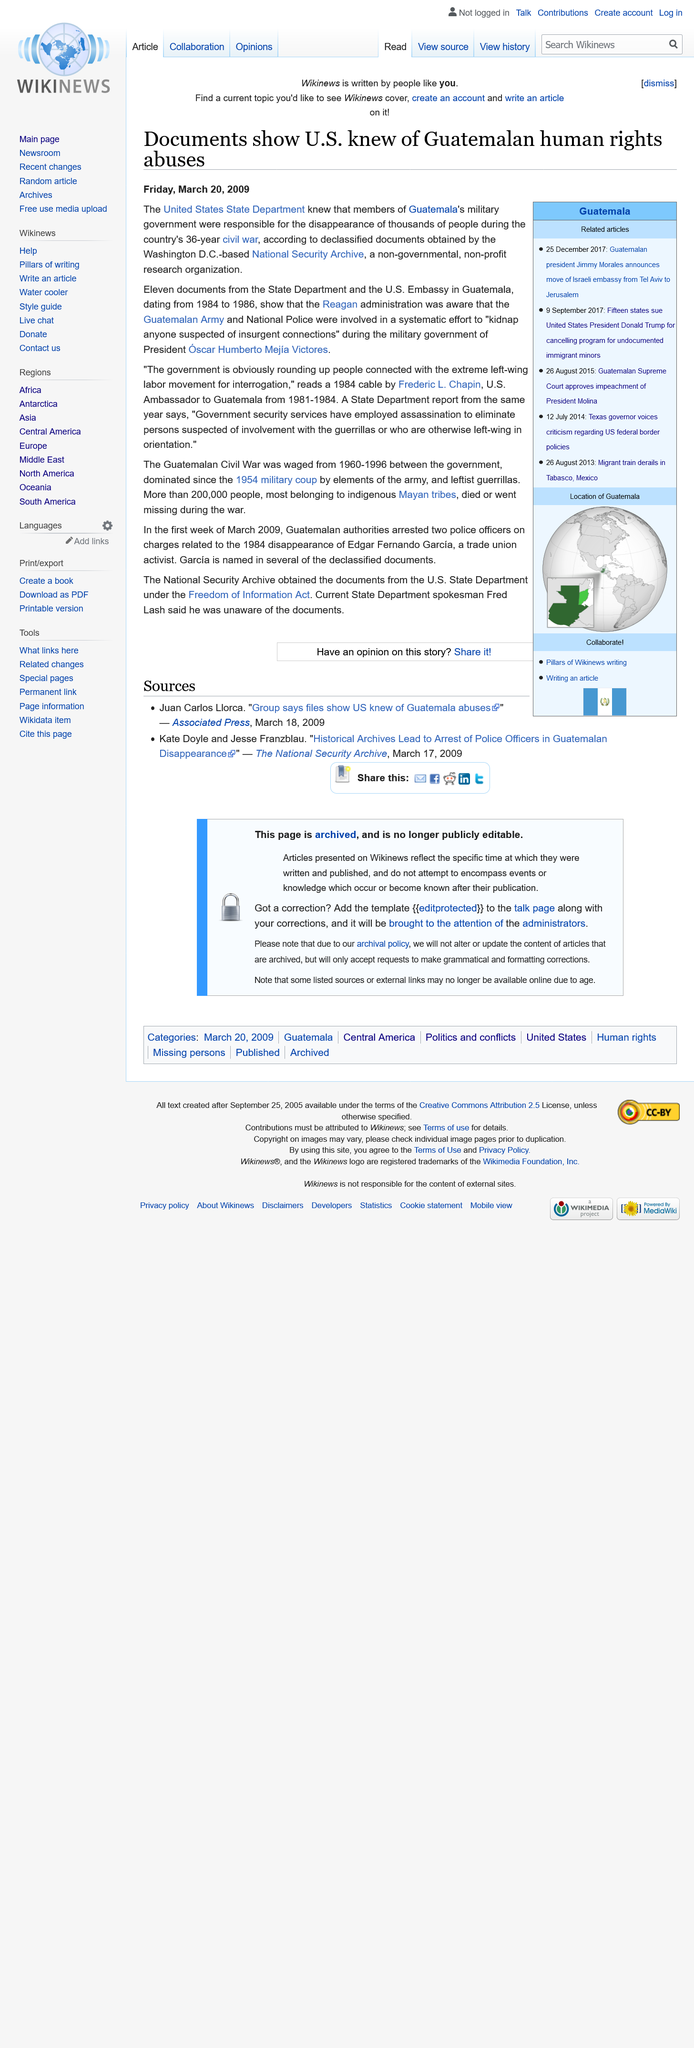Identify some key points in this picture. The article regarding U.S. knowledge of Guatemalan human rights abuses was published on Friday, March 20, 2009. The National Security Archive is based in Washington D.C., which is the city where it is located. The Guatemalan civil war lasted for 36 years. 